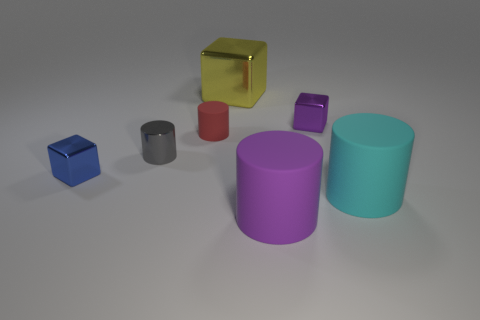Add 2 blue rubber things. How many objects exist? 9 Subtract all cubes. How many objects are left? 4 Subtract all cyan cylinders. Subtract all brown spheres. How many cylinders are left? 3 Subtract all green cubes. How many purple cylinders are left? 1 Subtract all tiny yellow matte objects. Subtract all big cyan cylinders. How many objects are left? 6 Add 3 purple matte things. How many purple matte things are left? 4 Add 2 tiny cyan things. How many tiny cyan things exist? 2 Subtract all red cylinders. How many cylinders are left? 3 Subtract all tiny blocks. How many blocks are left? 1 Subtract 1 red cylinders. How many objects are left? 6 